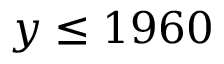Convert formula to latex. <formula><loc_0><loc_0><loc_500><loc_500>y \leq 1 9 6 0</formula> 